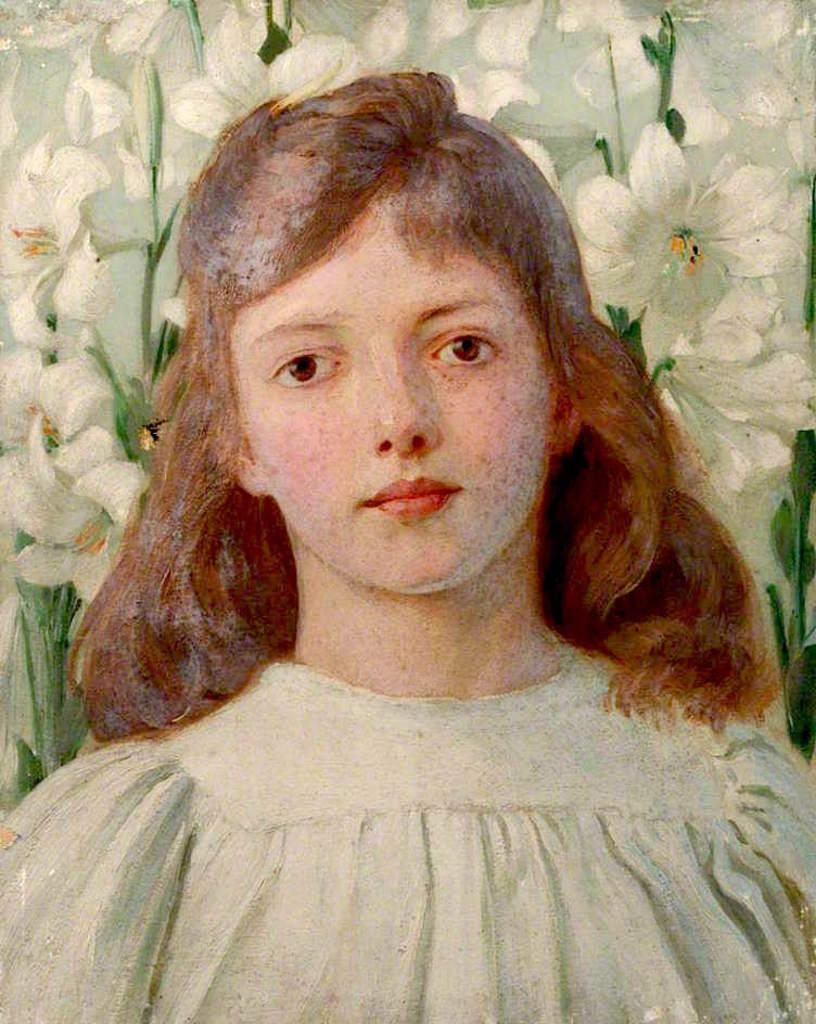What type of artwork is depicted in the image? The image is a painting. Who or what is the main subject of the painting? There is a girl in the painting. What can be seen in the background of the painting? There are flowers in the background of the painting. What type of destruction can be seen in the painting? There is no destruction depicted in the painting; it features a girl and flowers in the background. What type of chess pieces are present in the painting? There are no chess pieces present in the painting. 